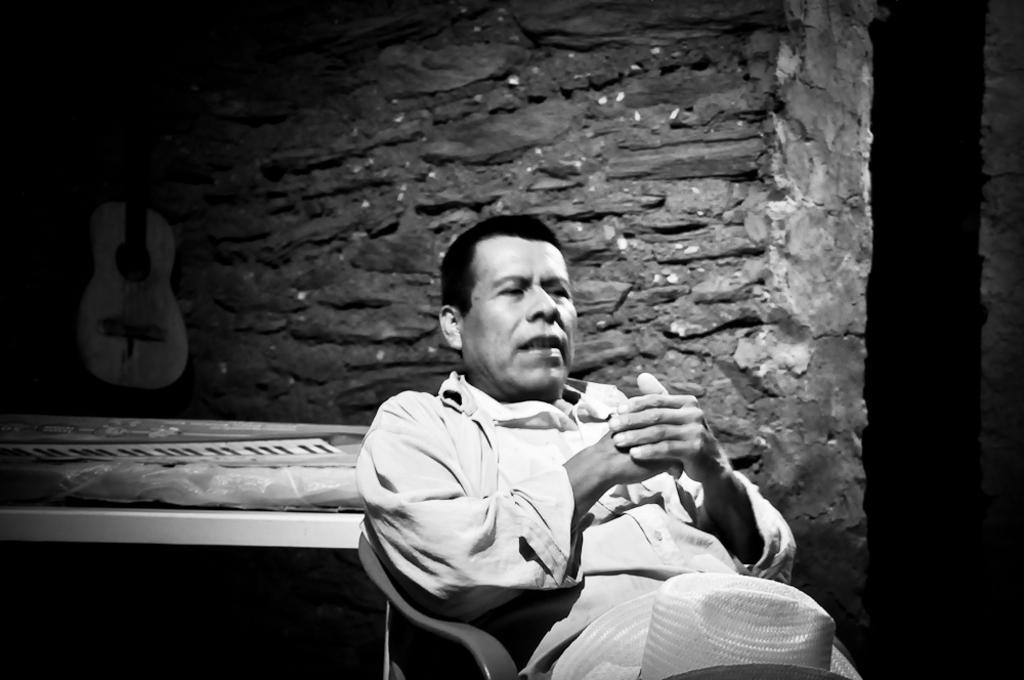Could you give a brief overview of what you see in this image? This is a black and white image. In the center of the image we can see a man is sitting on a chair and also we can see a hat. In the background of the image we can see the wall, guitar, table. On the table we can see a plastic cover and paper. 